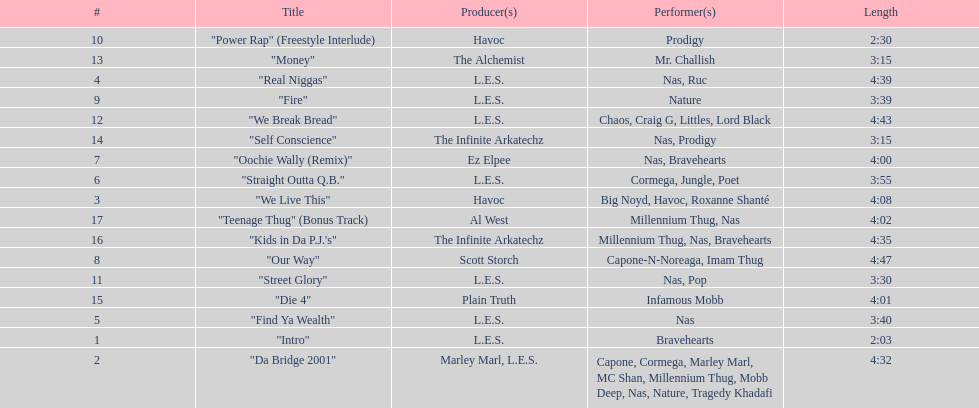Could you parse the entire table as a dict? {'header': ['#', 'Title', 'Producer(s)', 'Performer(s)', 'Length'], 'rows': [['10', '"Power Rap" (Freestyle Interlude)', 'Havoc', 'Prodigy', '2:30'], ['13', '"Money"', 'The Alchemist', 'Mr. Challish', '3:15'], ['4', '"Real Niggas"', 'L.E.S.', 'Nas, Ruc', '4:39'], ['9', '"Fire"', 'L.E.S.', 'Nature', '3:39'], ['12', '"We Break Bread"', 'L.E.S.', 'Chaos, Craig G, Littles, Lord Black', '4:43'], ['14', '"Self Conscience"', 'The Infinite Arkatechz', 'Nas, Prodigy', '3:15'], ['7', '"Oochie Wally (Remix)"', 'Ez Elpee', 'Nas, Bravehearts', '4:00'], ['6', '"Straight Outta Q.B."', 'L.E.S.', 'Cormega, Jungle, Poet', '3:55'], ['3', '"We Live This"', 'Havoc', 'Big Noyd, Havoc, Roxanne Shanté', '4:08'], ['17', '"Teenage Thug" (Bonus Track)', 'Al West', 'Millennium Thug, Nas', '4:02'], ['16', '"Kids in Da P.J.\'s"', 'The Infinite Arkatechz', 'Millennium Thug, Nas, Bravehearts', '4:35'], ['8', '"Our Way"', 'Scott Storch', 'Capone-N-Noreaga, Imam Thug', '4:47'], ['11', '"Street Glory"', 'L.E.S.', 'Nas, Pop', '3:30'], ['15', '"Die 4"', 'Plain Truth', 'Infamous Mobb', '4:01'], ['5', '"Find Ya Wealth"', 'L.E.S.', 'Nas', '3:40'], ['1', '"Intro"', 'L.E.S.', 'Bravehearts', '2:03'], ['2', '"Da Bridge 2001"', 'Marley Marl, L.E.S.', 'Capone, Cormega, Marley Marl, MC Shan, Millennium Thug, Mobb Deep, Nas, Nature, Tragedy Khadafi', '4:32']]} What is the first song on the album produced by havoc? "We Live This". 